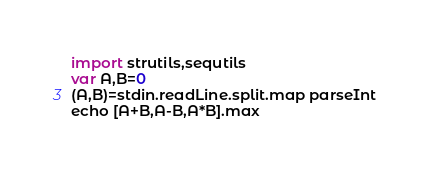Convert code to text. <code><loc_0><loc_0><loc_500><loc_500><_Nim_>import strutils,sequtils
var A,B=0
(A,B)=stdin.readLine.split.map parseInt
echo [A+B,A-B,A*B].max</code> 